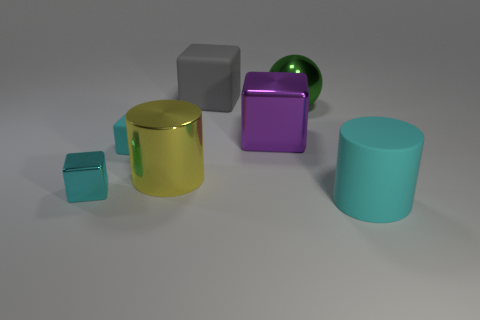Subtract all small rubber blocks. How many blocks are left? 3 Add 1 tiny brown spheres. How many objects exist? 8 Subtract all cyan cylinders. How many cylinders are left? 1 Subtract 2 blocks. How many blocks are left? 2 Subtract all blue cylinders. How many cyan blocks are left? 2 Add 1 large shiny cylinders. How many large shiny cylinders are left? 2 Add 2 large yellow cylinders. How many large yellow cylinders exist? 3 Subtract 1 green balls. How many objects are left? 6 Subtract all balls. How many objects are left? 6 Subtract all brown cylinders. Subtract all gray spheres. How many cylinders are left? 2 